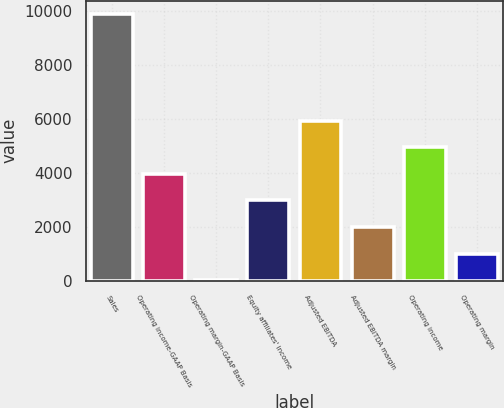Convert chart. <chart><loc_0><loc_0><loc_500><loc_500><bar_chart><fcel>Sales<fcel>Operating income-GAAP Basis<fcel>Operating margin-GAAP Basis<fcel>Equity affiliates' income<fcel>Adjusted EBITDA<fcel>Adjusted EBITDA margin<fcel>Operating income<fcel>Operating margin<nl><fcel>9894.9<fcel>3968.34<fcel>17.3<fcel>2980.58<fcel>5943.86<fcel>1992.82<fcel>4956.1<fcel>1005.06<nl></chart> 